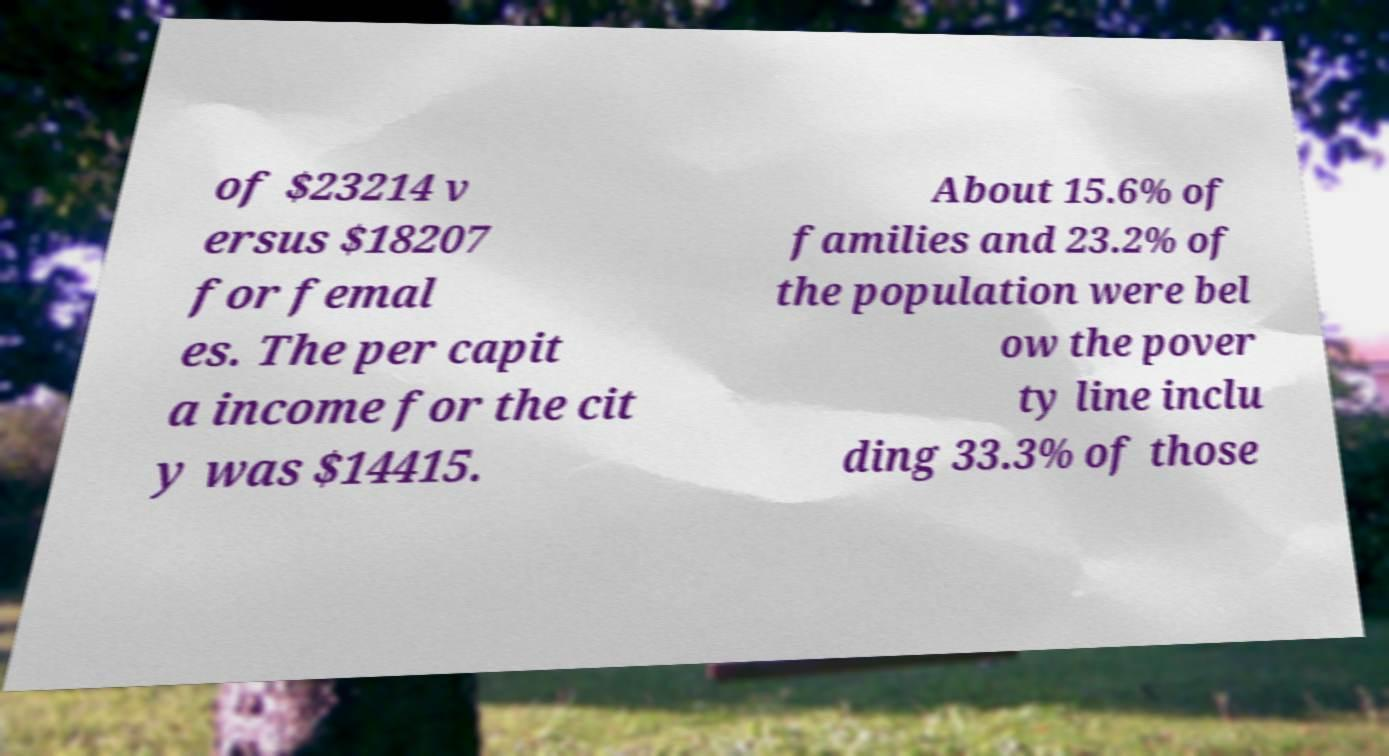For documentation purposes, I need the text within this image transcribed. Could you provide that? of $23214 v ersus $18207 for femal es. The per capit a income for the cit y was $14415. About 15.6% of families and 23.2% of the population were bel ow the pover ty line inclu ding 33.3% of those 